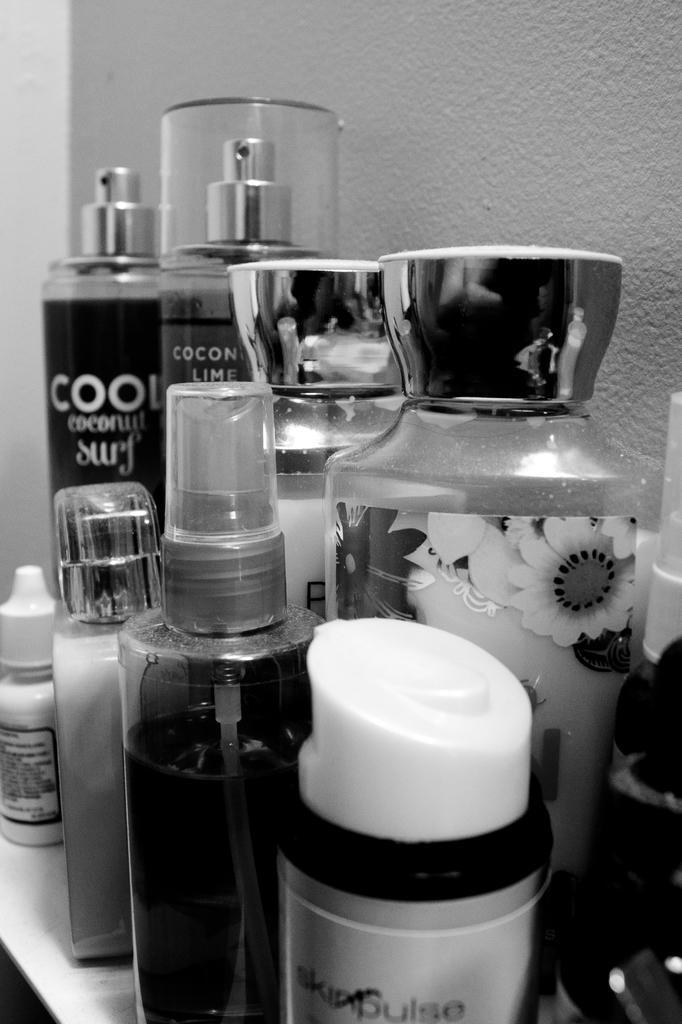Could you give a brief overview of what you see in this image? As we can see in the picture that, there are many perfumes which are in different sizes of bottle. 